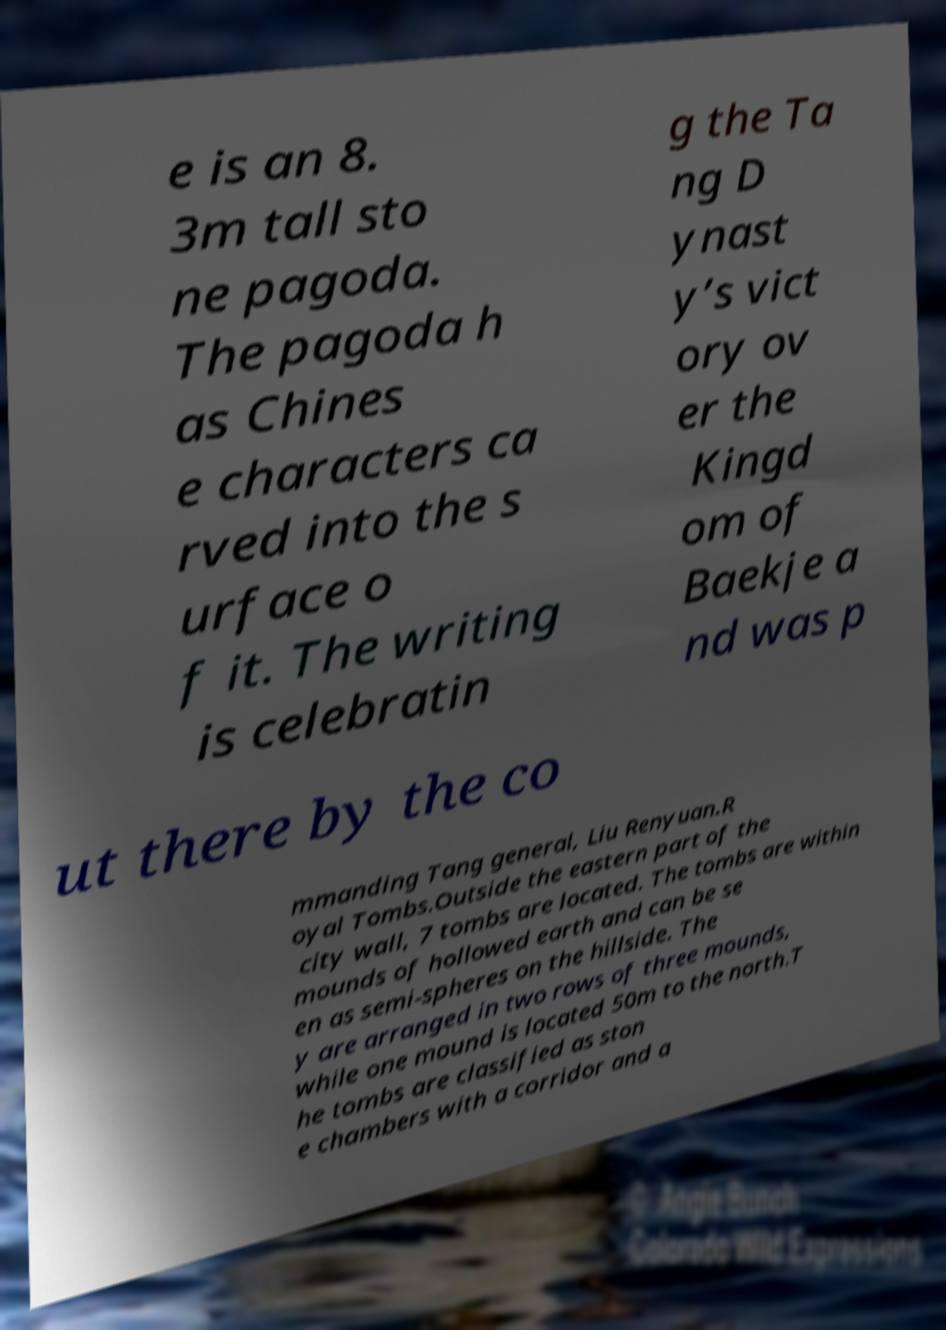Could you extract and type out the text from this image? e is an 8. 3m tall sto ne pagoda. The pagoda h as Chines e characters ca rved into the s urface o f it. The writing is celebratin g the Ta ng D ynast y’s vict ory ov er the Kingd om of Baekje a nd was p ut there by the co mmanding Tang general, Liu Renyuan.R oyal Tombs.Outside the eastern part of the city wall, 7 tombs are located. The tombs are within mounds of hollowed earth and can be se en as semi-spheres on the hillside. The y are arranged in two rows of three mounds, while one mound is located 50m to the north.T he tombs are classified as ston e chambers with a corridor and a 